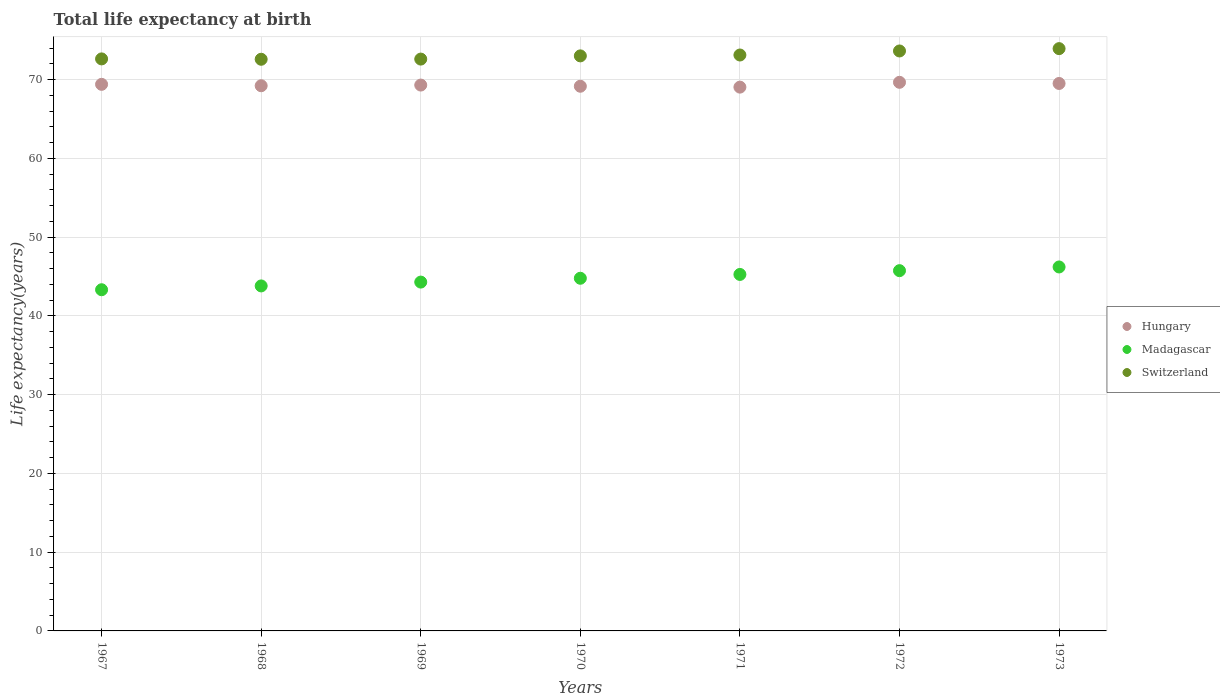How many different coloured dotlines are there?
Offer a very short reply. 3. Is the number of dotlines equal to the number of legend labels?
Offer a terse response. Yes. What is the life expectancy at birth in in Madagascar in 1968?
Make the answer very short. 43.81. Across all years, what is the maximum life expectancy at birth in in Switzerland?
Your response must be concise. 73.94. Across all years, what is the minimum life expectancy at birth in in Hungary?
Your answer should be compact. 69.05. In which year was the life expectancy at birth in in Hungary maximum?
Offer a terse response. 1972. In which year was the life expectancy at birth in in Switzerland minimum?
Offer a very short reply. 1968. What is the total life expectancy at birth in in Switzerland in the graph?
Your response must be concise. 511.58. What is the difference between the life expectancy at birth in in Switzerland in 1968 and that in 1971?
Provide a succinct answer. -0.54. What is the difference between the life expectancy at birth in in Madagascar in 1973 and the life expectancy at birth in in Hungary in 1969?
Ensure brevity in your answer.  -23.1. What is the average life expectancy at birth in in Switzerland per year?
Provide a short and direct response. 73.08. In the year 1971, what is the difference between the life expectancy at birth in in Madagascar and life expectancy at birth in in Hungary?
Ensure brevity in your answer.  -23.79. What is the ratio of the life expectancy at birth in in Madagascar in 1970 to that in 1972?
Offer a terse response. 0.98. Is the life expectancy at birth in in Hungary in 1970 less than that in 1973?
Give a very brief answer. Yes. Is the difference between the life expectancy at birth in in Madagascar in 1967 and 1972 greater than the difference between the life expectancy at birth in in Hungary in 1967 and 1972?
Provide a succinct answer. No. What is the difference between the highest and the second highest life expectancy at birth in in Hungary?
Provide a short and direct response. 0.15. What is the difference between the highest and the lowest life expectancy at birth in in Madagascar?
Your response must be concise. 2.89. Does the life expectancy at birth in in Switzerland monotonically increase over the years?
Ensure brevity in your answer.  No. Is the life expectancy at birth in in Madagascar strictly less than the life expectancy at birth in in Hungary over the years?
Ensure brevity in your answer.  Yes. How many dotlines are there?
Offer a very short reply. 3. Does the graph contain grids?
Your response must be concise. Yes. Where does the legend appear in the graph?
Provide a short and direct response. Center right. How are the legend labels stacked?
Offer a very short reply. Vertical. What is the title of the graph?
Provide a succinct answer. Total life expectancy at birth. Does "Mexico" appear as one of the legend labels in the graph?
Offer a very short reply. No. What is the label or title of the X-axis?
Provide a short and direct response. Years. What is the label or title of the Y-axis?
Provide a succinct answer. Life expectancy(years). What is the Life expectancy(years) in Hungary in 1967?
Your answer should be compact. 69.41. What is the Life expectancy(years) of Madagascar in 1967?
Give a very brief answer. 43.32. What is the Life expectancy(years) in Switzerland in 1967?
Make the answer very short. 72.64. What is the Life expectancy(years) of Hungary in 1968?
Offer a very short reply. 69.23. What is the Life expectancy(years) in Madagascar in 1968?
Offer a very short reply. 43.81. What is the Life expectancy(years) of Switzerland in 1968?
Provide a short and direct response. 72.59. What is the Life expectancy(years) in Hungary in 1969?
Your answer should be very brief. 69.31. What is the Life expectancy(years) of Madagascar in 1969?
Provide a succinct answer. 44.3. What is the Life expectancy(years) of Switzerland in 1969?
Your answer should be very brief. 72.61. What is the Life expectancy(years) in Hungary in 1970?
Provide a short and direct response. 69.16. What is the Life expectancy(years) of Madagascar in 1970?
Your answer should be very brief. 44.78. What is the Life expectancy(years) in Switzerland in 1970?
Your answer should be compact. 73.02. What is the Life expectancy(years) in Hungary in 1971?
Give a very brief answer. 69.05. What is the Life expectancy(years) in Madagascar in 1971?
Offer a very short reply. 45.27. What is the Life expectancy(years) of Switzerland in 1971?
Give a very brief answer. 73.13. What is the Life expectancy(years) in Hungary in 1972?
Provide a succinct answer. 69.66. What is the Life expectancy(years) of Madagascar in 1972?
Keep it short and to the point. 45.75. What is the Life expectancy(years) of Switzerland in 1972?
Offer a very short reply. 73.64. What is the Life expectancy(years) in Hungary in 1973?
Your response must be concise. 69.52. What is the Life expectancy(years) of Madagascar in 1973?
Make the answer very short. 46.22. What is the Life expectancy(years) in Switzerland in 1973?
Offer a terse response. 73.94. Across all years, what is the maximum Life expectancy(years) of Hungary?
Provide a succinct answer. 69.66. Across all years, what is the maximum Life expectancy(years) of Madagascar?
Your response must be concise. 46.22. Across all years, what is the maximum Life expectancy(years) in Switzerland?
Offer a very short reply. 73.94. Across all years, what is the minimum Life expectancy(years) of Hungary?
Give a very brief answer. 69.05. Across all years, what is the minimum Life expectancy(years) in Madagascar?
Your answer should be very brief. 43.32. Across all years, what is the minimum Life expectancy(years) in Switzerland?
Your response must be concise. 72.59. What is the total Life expectancy(years) in Hungary in the graph?
Provide a succinct answer. 485.35. What is the total Life expectancy(years) in Madagascar in the graph?
Your response must be concise. 313.44. What is the total Life expectancy(years) of Switzerland in the graph?
Make the answer very short. 511.58. What is the difference between the Life expectancy(years) in Hungary in 1967 and that in 1968?
Make the answer very short. 0.18. What is the difference between the Life expectancy(years) in Madagascar in 1967 and that in 1968?
Provide a short and direct response. -0.48. What is the difference between the Life expectancy(years) of Switzerland in 1967 and that in 1968?
Give a very brief answer. 0.05. What is the difference between the Life expectancy(years) of Hungary in 1967 and that in 1969?
Keep it short and to the point. 0.09. What is the difference between the Life expectancy(years) of Madagascar in 1967 and that in 1969?
Make the answer very short. -0.97. What is the difference between the Life expectancy(years) in Switzerland in 1967 and that in 1969?
Keep it short and to the point. 0.02. What is the difference between the Life expectancy(years) in Hungary in 1967 and that in 1970?
Ensure brevity in your answer.  0.24. What is the difference between the Life expectancy(years) in Madagascar in 1967 and that in 1970?
Make the answer very short. -1.46. What is the difference between the Life expectancy(years) in Switzerland in 1967 and that in 1970?
Your response must be concise. -0.38. What is the difference between the Life expectancy(years) in Hungary in 1967 and that in 1971?
Your answer should be compact. 0.35. What is the difference between the Life expectancy(years) in Madagascar in 1967 and that in 1971?
Provide a short and direct response. -1.94. What is the difference between the Life expectancy(years) in Switzerland in 1967 and that in 1971?
Make the answer very short. -0.49. What is the difference between the Life expectancy(years) in Hungary in 1967 and that in 1972?
Keep it short and to the point. -0.26. What is the difference between the Life expectancy(years) of Madagascar in 1967 and that in 1972?
Make the answer very short. -2.42. What is the difference between the Life expectancy(years) in Switzerland in 1967 and that in 1972?
Offer a very short reply. -1.01. What is the difference between the Life expectancy(years) of Hungary in 1967 and that in 1973?
Your answer should be compact. -0.11. What is the difference between the Life expectancy(years) in Madagascar in 1967 and that in 1973?
Provide a succinct answer. -2.89. What is the difference between the Life expectancy(years) in Switzerland in 1967 and that in 1973?
Offer a very short reply. -1.3. What is the difference between the Life expectancy(years) of Hungary in 1968 and that in 1969?
Make the answer very short. -0.08. What is the difference between the Life expectancy(years) in Madagascar in 1968 and that in 1969?
Offer a very short reply. -0.49. What is the difference between the Life expectancy(years) in Switzerland in 1968 and that in 1969?
Provide a short and direct response. -0.02. What is the difference between the Life expectancy(years) in Hungary in 1968 and that in 1970?
Give a very brief answer. 0.07. What is the difference between the Life expectancy(years) in Madagascar in 1968 and that in 1970?
Offer a very short reply. -0.97. What is the difference between the Life expectancy(years) of Switzerland in 1968 and that in 1970?
Your answer should be very brief. -0.43. What is the difference between the Life expectancy(years) of Hungary in 1968 and that in 1971?
Make the answer very short. 0.18. What is the difference between the Life expectancy(years) in Madagascar in 1968 and that in 1971?
Offer a terse response. -1.46. What is the difference between the Life expectancy(years) of Switzerland in 1968 and that in 1971?
Your response must be concise. -0.54. What is the difference between the Life expectancy(years) in Hungary in 1968 and that in 1972?
Offer a terse response. -0.43. What is the difference between the Life expectancy(years) of Madagascar in 1968 and that in 1972?
Make the answer very short. -1.94. What is the difference between the Life expectancy(years) of Switzerland in 1968 and that in 1972?
Keep it short and to the point. -1.05. What is the difference between the Life expectancy(years) of Hungary in 1968 and that in 1973?
Your response must be concise. -0.29. What is the difference between the Life expectancy(years) of Madagascar in 1968 and that in 1973?
Your answer should be compact. -2.41. What is the difference between the Life expectancy(years) of Switzerland in 1968 and that in 1973?
Offer a very short reply. -1.35. What is the difference between the Life expectancy(years) in Madagascar in 1969 and that in 1970?
Keep it short and to the point. -0.49. What is the difference between the Life expectancy(years) in Switzerland in 1969 and that in 1970?
Provide a succinct answer. -0.41. What is the difference between the Life expectancy(years) in Hungary in 1969 and that in 1971?
Provide a short and direct response. 0.26. What is the difference between the Life expectancy(years) in Madagascar in 1969 and that in 1971?
Keep it short and to the point. -0.97. What is the difference between the Life expectancy(years) in Switzerland in 1969 and that in 1971?
Your answer should be compact. -0.52. What is the difference between the Life expectancy(years) in Hungary in 1969 and that in 1972?
Provide a succinct answer. -0.35. What is the difference between the Life expectancy(years) of Madagascar in 1969 and that in 1972?
Keep it short and to the point. -1.45. What is the difference between the Life expectancy(years) of Switzerland in 1969 and that in 1972?
Offer a terse response. -1.03. What is the difference between the Life expectancy(years) of Hungary in 1969 and that in 1973?
Provide a succinct answer. -0.2. What is the difference between the Life expectancy(years) in Madagascar in 1969 and that in 1973?
Make the answer very short. -1.92. What is the difference between the Life expectancy(years) in Switzerland in 1969 and that in 1973?
Your answer should be very brief. -1.33. What is the difference between the Life expectancy(years) of Hungary in 1970 and that in 1971?
Give a very brief answer. 0.11. What is the difference between the Life expectancy(years) in Madagascar in 1970 and that in 1971?
Your answer should be compact. -0.48. What is the difference between the Life expectancy(years) in Switzerland in 1970 and that in 1971?
Keep it short and to the point. -0.11. What is the difference between the Life expectancy(years) of Madagascar in 1970 and that in 1972?
Ensure brevity in your answer.  -0.96. What is the difference between the Life expectancy(years) of Switzerland in 1970 and that in 1972?
Your answer should be compact. -0.62. What is the difference between the Life expectancy(years) of Hungary in 1970 and that in 1973?
Offer a very short reply. -0.35. What is the difference between the Life expectancy(years) in Madagascar in 1970 and that in 1973?
Provide a succinct answer. -1.43. What is the difference between the Life expectancy(years) of Switzerland in 1970 and that in 1973?
Provide a short and direct response. -0.92. What is the difference between the Life expectancy(years) in Hungary in 1971 and that in 1972?
Your answer should be compact. -0.61. What is the difference between the Life expectancy(years) of Madagascar in 1971 and that in 1972?
Make the answer very short. -0.48. What is the difference between the Life expectancy(years) in Switzerland in 1971 and that in 1972?
Your answer should be very brief. -0.51. What is the difference between the Life expectancy(years) in Hungary in 1971 and that in 1973?
Give a very brief answer. -0.47. What is the difference between the Life expectancy(years) of Madagascar in 1971 and that in 1973?
Make the answer very short. -0.95. What is the difference between the Life expectancy(years) of Switzerland in 1971 and that in 1973?
Ensure brevity in your answer.  -0.81. What is the difference between the Life expectancy(years) in Hungary in 1972 and that in 1973?
Keep it short and to the point. 0.15. What is the difference between the Life expectancy(years) in Madagascar in 1972 and that in 1973?
Ensure brevity in your answer.  -0.47. What is the difference between the Life expectancy(years) in Switzerland in 1972 and that in 1973?
Keep it short and to the point. -0.3. What is the difference between the Life expectancy(years) in Hungary in 1967 and the Life expectancy(years) in Madagascar in 1968?
Ensure brevity in your answer.  25.6. What is the difference between the Life expectancy(years) of Hungary in 1967 and the Life expectancy(years) of Switzerland in 1968?
Your response must be concise. -3.18. What is the difference between the Life expectancy(years) of Madagascar in 1967 and the Life expectancy(years) of Switzerland in 1968?
Provide a short and direct response. -29.27. What is the difference between the Life expectancy(years) in Hungary in 1967 and the Life expectancy(years) in Madagascar in 1969?
Give a very brief answer. 25.11. What is the difference between the Life expectancy(years) in Hungary in 1967 and the Life expectancy(years) in Switzerland in 1969?
Ensure brevity in your answer.  -3.21. What is the difference between the Life expectancy(years) of Madagascar in 1967 and the Life expectancy(years) of Switzerland in 1969?
Provide a succinct answer. -29.29. What is the difference between the Life expectancy(years) in Hungary in 1967 and the Life expectancy(years) in Madagascar in 1970?
Offer a very short reply. 24.62. What is the difference between the Life expectancy(years) in Hungary in 1967 and the Life expectancy(years) in Switzerland in 1970?
Keep it short and to the point. -3.61. What is the difference between the Life expectancy(years) of Madagascar in 1967 and the Life expectancy(years) of Switzerland in 1970?
Give a very brief answer. -29.7. What is the difference between the Life expectancy(years) of Hungary in 1967 and the Life expectancy(years) of Madagascar in 1971?
Provide a succinct answer. 24.14. What is the difference between the Life expectancy(years) of Hungary in 1967 and the Life expectancy(years) of Switzerland in 1971?
Your answer should be very brief. -3.72. What is the difference between the Life expectancy(years) of Madagascar in 1967 and the Life expectancy(years) of Switzerland in 1971?
Give a very brief answer. -29.81. What is the difference between the Life expectancy(years) in Hungary in 1967 and the Life expectancy(years) in Madagascar in 1972?
Give a very brief answer. 23.66. What is the difference between the Life expectancy(years) in Hungary in 1967 and the Life expectancy(years) in Switzerland in 1972?
Your response must be concise. -4.24. What is the difference between the Life expectancy(years) of Madagascar in 1967 and the Life expectancy(years) of Switzerland in 1972?
Your answer should be very brief. -30.32. What is the difference between the Life expectancy(years) of Hungary in 1967 and the Life expectancy(years) of Madagascar in 1973?
Make the answer very short. 23.19. What is the difference between the Life expectancy(years) of Hungary in 1967 and the Life expectancy(years) of Switzerland in 1973?
Provide a short and direct response. -4.53. What is the difference between the Life expectancy(years) in Madagascar in 1967 and the Life expectancy(years) in Switzerland in 1973?
Make the answer very short. -30.62. What is the difference between the Life expectancy(years) in Hungary in 1968 and the Life expectancy(years) in Madagascar in 1969?
Ensure brevity in your answer.  24.93. What is the difference between the Life expectancy(years) in Hungary in 1968 and the Life expectancy(years) in Switzerland in 1969?
Offer a terse response. -3.38. What is the difference between the Life expectancy(years) of Madagascar in 1968 and the Life expectancy(years) of Switzerland in 1969?
Provide a short and direct response. -28.8. What is the difference between the Life expectancy(years) in Hungary in 1968 and the Life expectancy(years) in Madagascar in 1970?
Make the answer very short. 24.45. What is the difference between the Life expectancy(years) of Hungary in 1968 and the Life expectancy(years) of Switzerland in 1970?
Your answer should be very brief. -3.79. What is the difference between the Life expectancy(years) in Madagascar in 1968 and the Life expectancy(years) in Switzerland in 1970?
Your answer should be compact. -29.21. What is the difference between the Life expectancy(years) in Hungary in 1968 and the Life expectancy(years) in Madagascar in 1971?
Your answer should be compact. 23.96. What is the difference between the Life expectancy(years) in Hungary in 1968 and the Life expectancy(years) in Switzerland in 1971?
Offer a very short reply. -3.9. What is the difference between the Life expectancy(years) in Madagascar in 1968 and the Life expectancy(years) in Switzerland in 1971?
Keep it short and to the point. -29.32. What is the difference between the Life expectancy(years) of Hungary in 1968 and the Life expectancy(years) of Madagascar in 1972?
Offer a very short reply. 23.48. What is the difference between the Life expectancy(years) of Hungary in 1968 and the Life expectancy(years) of Switzerland in 1972?
Provide a short and direct response. -4.41. What is the difference between the Life expectancy(years) of Madagascar in 1968 and the Life expectancy(years) of Switzerland in 1972?
Keep it short and to the point. -29.84. What is the difference between the Life expectancy(years) in Hungary in 1968 and the Life expectancy(years) in Madagascar in 1973?
Provide a short and direct response. 23.01. What is the difference between the Life expectancy(years) of Hungary in 1968 and the Life expectancy(years) of Switzerland in 1973?
Your response must be concise. -4.71. What is the difference between the Life expectancy(years) of Madagascar in 1968 and the Life expectancy(years) of Switzerland in 1973?
Offer a terse response. -30.13. What is the difference between the Life expectancy(years) in Hungary in 1969 and the Life expectancy(years) in Madagascar in 1970?
Provide a succinct answer. 24.53. What is the difference between the Life expectancy(years) of Hungary in 1969 and the Life expectancy(years) of Switzerland in 1970?
Provide a succinct answer. -3.71. What is the difference between the Life expectancy(years) of Madagascar in 1969 and the Life expectancy(years) of Switzerland in 1970?
Make the answer very short. -28.72. What is the difference between the Life expectancy(years) of Hungary in 1969 and the Life expectancy(years) of Madagascar in 1971?
Make the answer very short. 24.05. What is the difference between the Life expectancy(years) of Hungary in 1969 and the Life expectancy(years) of Switzerland in 1971?
Your answer should be compact. -3.82. What is the difference between the Life expectancy(years) of Madagascar in 1969 and the Life expectancy(years) of Switzerland in 1971?
Your answer should be very brief. -28.84. What is the difference between the Life expectancy(years) in Hungary in 1969 and the Life expectancy(years) in Madagascar in 1972?
Offer a terse response. 23.57. What is the difference between the Life expectancy(years) of Hungary in 1969 and the Life expectancy(years) of Switzerland in 1972?
Provide a succinct answer. -4.33. What is the difference between the Life expectancy(years) of Madagascar in 1969 and the Life expectancy(years) of Switzerland in 1972?
Make the answer very short. -29.35. What is the difference between the Life expectancy(years) in Hungary in 1969 and the Life expectancy(years) in Madagascar in 1973?
Your response must be concise. 23.1. What is the difference between the Life expectancy(years) of Hungary in 1969 and the Life expectancy(years) of Switzerland in 1973?
Ensure brevity in your answer.  -4.63. What is the difference between the Life expectancy(years) of Madagascar in 1969 and the Life expectancy(years) of Switzerland in 1973?
Your response must be concise. -29.65. What is the difference between the Life expectancy(years) of Hungary in 1970 and the Life expectancy(years) of Madagascar in 1971?
Offer a very short reply. 23.9. What is the difference between the Life expectancy(years) in Hungary in 1970 and the Life expectancy(years) in Switzerland in 1971?
Offer a terse response. -3.97. What is the difference between the Life expectancy(years) of Madagascar in 1970 and the Life expectancy(years) of Switzerland in 1971?
Provide a succinct answer. -28.35. What is the difference between the Life expectancy(years) in Hungary in 1970 and the Life expectancy(years) in Madagascar in 1972?
Your answer should be very brief. 23.42. What is the difference between the Life expectancy(years) of Hungary in 1970 and the Life expectancy(years) of Switzerland in 1972?
Provide a succinct answer. -4.48. What is the difference between the Life expectancy(years) in Madagascar in 1970 and the Life expectancy(years) in Switzerland in 1972?
Your answer should be very brief. -28.86. What is the difference between the Life expectancy(years) of Hungary in 1970 and the Life expectancy(years) of Madagascar in 1973?
Provide a short and direct response. 22.95. What is the difference between the Life expectancy(years) of Hungary in 1970 and the Life expectancy(years) of Switzerland in 1973?
Make the answer very short. -4.78. What is the difference between the Life expectancy(years) in Madagascar in 1970 and the Life expectancy(years) in Switzerland in 1973?
Ensure brevity in your answer.  -29.16. What is the difference between the Life expectancy(years) of Hungary in 1971 and the Life expectancy(years) of Madagascar in 1972?
Provide a short and direct response. 23.31. What is the difference between the Life expectancy(years) in Hungary in 1971 and the Life expectancy(years) in Switzerland in 1972?
Provide a short and direct response. -4.59. What is the difference between the Life expectancy(years) in Madagascar in 1971 and the Life expectancy(years) in Switzerland in 1972?
Give a very brief answer. -28.38. What is the difference between the Life expectancy(years) in Hungary in 1971 and the Life expectancy(years) in Madagascar in 1973?
Your answer should be compact. 22.84. What is the difference between the Life expectancy(years) of Hungary in 1971 and the Life expectancy(years) of Switzerland in 1973?
Provide a succinct answer. -4.89. What is the difference between the Life expectancy(years) of Madagascar in 1971 and the Life expectancy(years) of Switzerland in 1973?
Keep it short and to the point. -28.67. What is the difference between the Life expectancy(years) of Hungary in 1972 and the Life expectancy(years) of Madagascar in 1973?
Ensure brevity in your answer.  23.45. What is the difference between the Life expectancy(years) in Hungary in 1972 and the Life expectancy(years) in Switzerland in 1973?
Offer a very short reply. -4.28. What is the difference between the Life expectancy(years) of Madagascar in 1972 and the Life expectancy(years) of Switzerland in 1973?
Provide a short and direct response. -28.19. What is the average Life expectancy(years) in Hungary per year?
Provide a short and direct response. 69.34. What is the average Life expectancy(years) of Madagascar per year?
Provide a short and direct response. 44.78. What is the average Life expectancy(years) of Switzerland per year?
Give a very brief answer. 73.08. In the year 1967, what is the difference between the Life expectancy(years) in Hungary and Life expectancy(years) in Madagascar?
Your answer should be compact. 26.08. In the year 1967, what is the difference between the Life expectancy(years) of Hungary and Life expectancy(years) of Switzerland?
Make the answer very short. -3.23. In the year 1967, what is the difference between the Life expectancy(years) in Madagascar and Life expectancy(years) in Switzerland?
Keep it short and to the point. -29.31. In the year 1968, what is the difference between the Life expectancy(years) in Hungary and Life expectancy(years) in Madagascar?
Your response must be concise. 25.42. In the year 1968, what is the difference between the Life expectancy(years) of Hungary and Life expectancy(years) of Switzerland?
Your response must be concise. -3.36. In the year 1968, what is the difference between the Life expectancy(years) in Madagascar and Life expectancy(years) in Switzerland?
Make the answer very short. -28.78. In the year 1969, what is the difference between the Life expectancy(years) of Hungary and Life expectancy(years) of Madagascar?
Your response must be concise. 25.02. In the year 1969, what is the difference between the Life expectancy(years) in Hungary and Life expectancy(years) in Switzerland?
Your response must be concise. -3.3. In the year 1969, what is the difference between the Life expectancy(years) of Madagascar and Life expectancy(years) of Switzerland?
Keep it short and to the point. -28.32. In the year 1970, what is the difference between the Life expectancy(years) of Hungary and Life expectancy(years) of Madagascar?
Your response must be concise. 24.38. In the year 1970, what is the difference between the Life expectancy(years) of Hungary and Life expectancy(years) of Switzerland?
Keep it short and to the point. -3.86. In the year 1970, what is the difference between the Life expectancy(years) of Madagascar and Life expectancy(years) of Switzerland?
Make the answer very short. -28.24. In the year 1971, what is the difference between the Life expectancy(years) in Hungary and Life expectancy(years) in Madagascar?
Your response must be concise. 23.79. In the year 1971, what is the difference between the Life expectancy(years) of Hungary and Life expectancy(years) of Switzerland?
Provide a succinct answer. -4.08. In the year 1971, what is the difference between the Life expectancy(years) of Madagascar and Life expectancy(years) of Switzerland?
Ensure brevity in your answer.  -27.86. In the year 1972, what is the difference between the Life expectancy(years) of Hungary and Life expectancy(years) of Madagascar?
Provide a short and direct response. 23.92. In the year 1972, what is the difference between the Life expectancy(years) in Hungary and Life expectancy(years) in Switzerland?
Your response must be concise. -3.98. In the year 1972, what is the difference between the Life expectancy(years) of Madagascar and Life expectancy(years) of Switzerland?
Your answer should be compact. -27.9. In the year 1973, what is the difference between the Life expectancy(years) of Hungary and Life expectancy(years) of Madagascar?
Give a very brief answer. 23.3. In the year 1973, what is the difference between the Life expectancy(years) in Hungary and Life expectancy(years) in Switzerland?
Your answer should be very brief. -4.42. In the year 1973, what is the difference between the Life expectancy(years) of Madagascar and Life expectancy(years) of Switzerland?
Keep it short and to the point. -27.72. What is the ratio of the Life expectancy(years) of Hungary in 1967 to that in 1968?
Provide a short and direct response. 1. What is the ratio of the Life expectancy(years) of Madagascar in 1967 to that in 1968?
Give a very brief answer. 0.99. What is the ratio of the Life expectancy(years) of Madagascar in 1967 to that in 1969?
Your answer should be compact. 0.98. What is the ratio of the Life expectancy(years) in Hungary in 1967 to that in 1970?
Your response must be concise. 1. What is the ratio of the Life expectancy(years) in Madagascar in 1967 to that in 1970?
Your answer should be very brief. 0.97. What is the ratio of the Life expectancy(years) in Switzerland in 1967 to that in 1970?
Ensure brevity in your answer.  0.99. What is the ratio of the Life expectancy(years) in Hungary in 1967 to that in 1971?
Offer a very short reply. 1.01. What is the ratio of the Life expectancy(years) in Madagascar in 1967 to that in 1971?
Provide a succinct answer. 0.96. What is the ratio of the Life expectancy(years) in Switzerland in 1967 to that in 1971?
Make the answer very short. 0.99. What is the ratio of the Life expectancy(years) of Madagascar in 1967 to that in 1972?
Your response must be concise. 0.95. What is the ratio of the Life expectancy(years) of Switzerland in 1967 to that in 1972?
Your answer should be very brief. 0.99. What is the ratio of the Life expectancy(years) of Madagascar in 1967 to that in 1973?
Keep it short and to the point. 0.94. What is the ratio of the Life expectancy(years) of Switzerland in 1967 to that in 1973?
Your response must be concise. 0.98. What is the ratio of the Life expectancy(years) in Madagascar in 1968 to that in 1969?
Your answer should be very brief. 0.99. What is the ratio of the Life expectancy(years) of Madagascar in 1968 to that in 1970?
Provide a succinct answer. 0.98. What is the ratio of the Life expectancy(years) in Madagascar in 1968 to that in 1971?
Offer a terse response. 0.97. What is the ratio of the Life expectancy(years) in Madagascar in 1968 to that in 1972?
Your answer should be compact. 0.96. What is the ratio of the Life expectancy(years) in Switzerland in 1968 to that in 1972?
Offer a terse response. 0.99. What is the ratio of the Life expectancy(years) in Madagascar in 1968 to that in 1973?
Your answer should be very brief. 0.95. What is the ratio of the Life expectancy(years) in Switzerland in 1968 to that in 1973?
Ensure brevity in your answer.  0.98. What is the ratio of the Life expectancy(years) of Madagascar in 1969 to that in 1970?
Provide a succinct answer. 0.99. What is the ratio of the Life expectancy(years) of Switzerland in 1969 to that in 1970?
Make the answer very short. 0.99. What is the ratio of the Life expectancy(years) in Madagascar in 1969 to that in 1971?
Provide a short and direct response. 0.98. What is the ratio of the Life expectancy(years) in Switzerland in 1969 to that in 1971?
Your answer should be very brief. 0.99. What is the ratio of the Life expectancy(years) of Madagascar in 1969 to that in 1972?
Make the answer very short. 0.97. What is the ratio of the Life expectancy(years) of Madagascar in 1969 to that in 1973?
Provide a short and direct response. 0.96. What is the ratio of the Life expectancy(years) in Switzerland in 1969 to that in 1973?
Your answer should be very brief. 0.98. What is the ratio of the Life expectancy(years) in Madagascar in 1970 to that in 1971?
Make the answer very short. 0.99. What is the ratio of the Life expectancy(years) of Madagascar in 1970 to that in 1972?
Ensure brevity in your answer.  0.98. What is the ratio of the Life expectancy(years) of Hungary in 1970 to that in 1973?
Provide a succinct answer. 0.99. What is the ratio of the Life expectancy(years) of Switzerland in 1970 to that in 1973?
Offer a terse response. 0.99. What is the ratio of the Life expectancy(years) of Hungary in 1971 to that in 1972?
Keep it short and to the point. 0.99. What is the ratio of the Life expectancy(years) in Madagascar in 1971 to that in 1972?
Offer a terse response. 0.99. What is the ratio of the Life expectancy(years) in Switzerland in 1971 to that in 1972?
Provide a succinct answer. 0.99. What is the ratio of the Life expectancy(years) in Hungary in 1971 to that in 1973?
Offer a terse response. 0.99. What is the ratio of the Life expectancy(years) of Madagascar in 1971 to that in 1973?
Your answer should be very brief. 0.98. What is the ratio of the Life expectancy(years) in Switzerland in 1971 to that in 1973?
Give a very brief answer. 0.99. What is the ratio of the Life expectancy(years) of Switzerland in 1972 to that in 1973?
Offer a very short reply. 1. What is the difference between the highest and the second highest Life expectancy(years) in Hungary?
Ensure brevity in your answer.  0.15. What is the difference between the highest and the second highest Life expectancy(years) in Madagascar?
Provide a succinct answer. 0.47. What is the difference between the highest and the second highest Life expectancy(years) of Switzerland?
Your response must be concise. 0.3. What is the difference between the highest and the lowest Life expectancy(years) in Hungary?
Keep it short and to the point. 0.61. What is the difference between the highest and the lowest Life expectancy(years) of Madagascar?
Give a very brief answer. 2.89. What is the difference between the highest and the lowest Life expectancy(years) of Switzerland?
Ensure brevity in your answer.  1.35. 